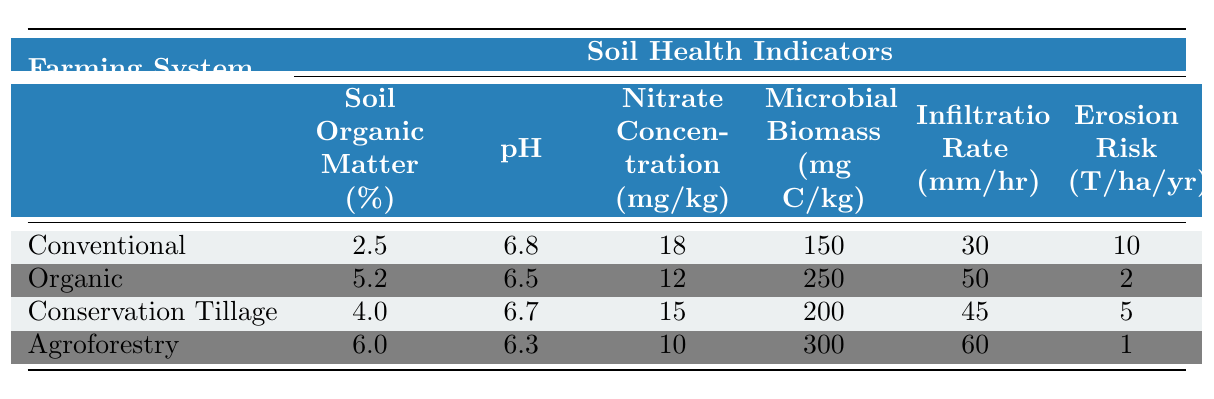What is the Soil Organic Matter percentage for the Agroforestry system? The Agroforestry system has a Soil Organic Matter percentage listed in the table as 6.0%.
Answer: 6.0% Which farming system has the highest Nitrate Concentration? Upon checking the table, the Conventional farming system has the highest Nitrate Concentration at 18 mg/kg.
Answer: Conventional What is the average pH across all farming systems? To find the average pH, we add the pH values: 6.8 + 6.5 + 6.7 + 6.3 = 26.3, and then divide by the number of systems (4), giving us an average pH of 26.3 / 4 = 6.575.
Answer: 6.575 Is the Erosion Risk for Organic farming higher than for Agroforestry? The table shows that the Erosion Risk for Organic farming is 2 T/ha/yr, while for Agroforestry it is 1 T/ha/yr. Therefore, the statement is false.
Answer: No What is the difference in Microbial Biomass between Organic and Conventional systems? The Microbial Biomass for Organic is 250 mg C/kg and for Conventional is 150 mg C/kg. The difference is 250 - 150 = 100 mg C/kg.
Answer: 100 mg C/kg Which farming system has the best Infiltration Rate and what is its value? Looking at the table, the Agroforestry system has the highest Infiltration Rate at 60 mm/hr.
Answer: Agroforestry, 60 mm/hr Which farming system shows the least Erosion Risk? The table indicates that Agroforestry shows the least Erosion Risk at 1 T/ha/yr, which is lower than all other systems.
Answer: Agroforestry If we consider the Soil Organic Matter of both Conservation Tillage and Organic systems, what is their combined value? The Soil Organic Matter for Conservation Tillage is 4.0% and for Organic it is 5.2%. The combined value is 4.0 + 5.2 = 9.2%.
Answer: 9.2% Is the pH value for Organic farming greater than that for Conservation Tillage? The table shows a pH of 6.5 for Organic and 6.7 for Conservation Tillage. Since 6.5 is not greater than 6.7, this statement is false.
Answer: No What is the overall trend of Soil Organic Matter as we move from Conventional to Agroforestry? By reviewing the table data, Soil Organic Matter increases from Conventional (2.5%) to Agroforestry (6.0%), indicating a positive trend.
Answer: Positive trend 